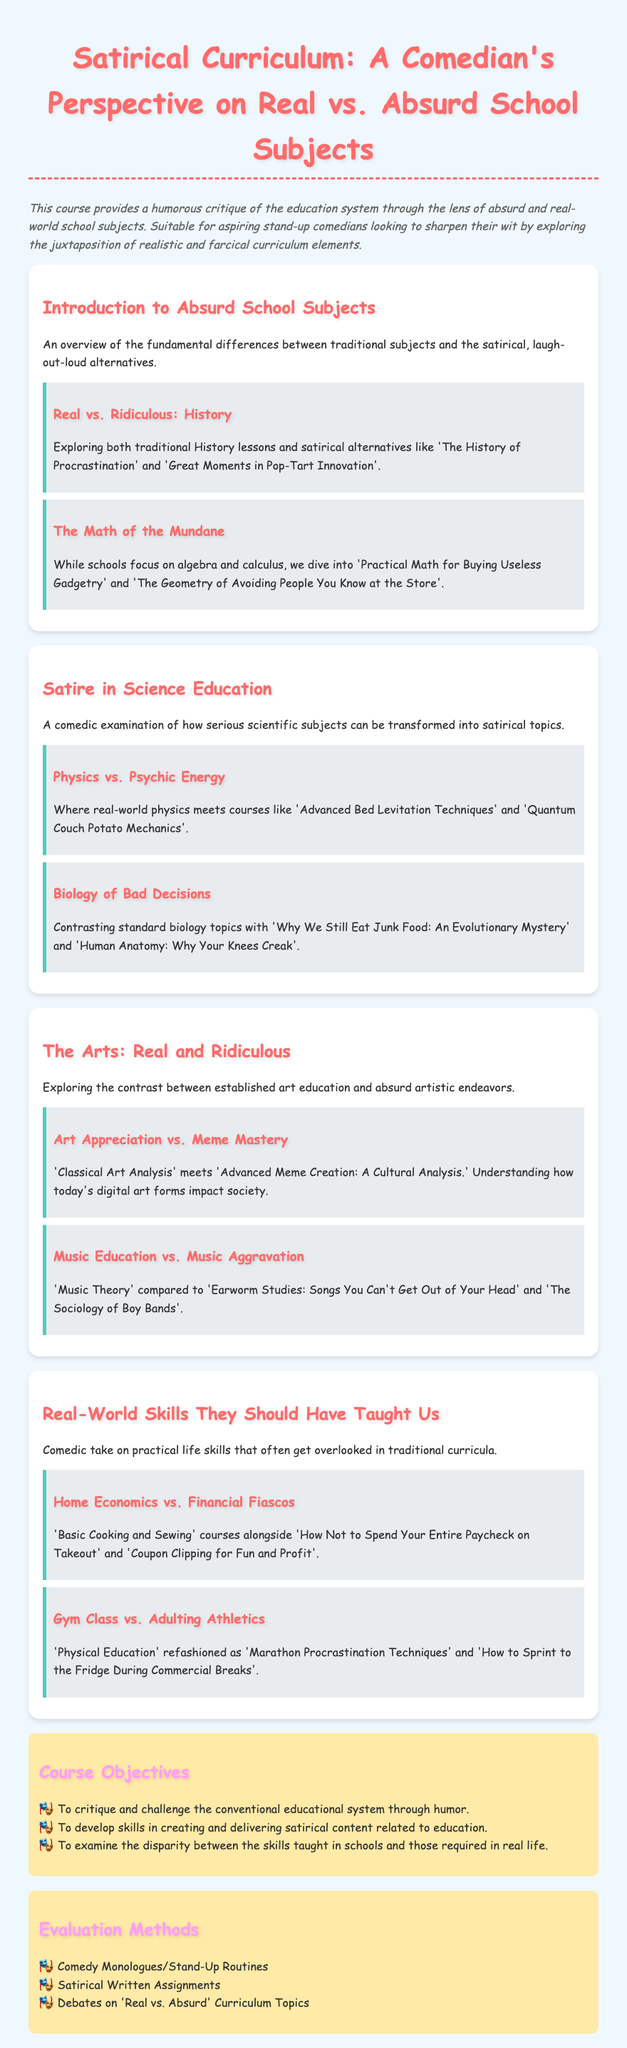What is the course title? The course title is mentioned at the top of the syllabus.
Answer: Satirical Curriculum: A Comedian's Perspective on Real vs. Absurd School Subjects How many units are there in the syllabus? The syllabus lists several distinct sections, each categorized as a unit.
Answer: Four What is the main objective of the course? The objectives section outlines the key aims of the course.
Answer: To critique and challenge the conventional educational system through humor Name one absurd school subject mentioned in the syllabus. The syllabus provides examples of humorous subjects within its content.
Answer: The History of Procrastination What is one of the evaluation methods listed? The evaluation section specifies ways students will be assessed throughout the course.
Answer: Comedy Monologues/Stand-Up Routines What type of humor does this syllabus primarily focus on? The course description explains the overarching theme of the syllabus.
Answer: Satirical What is the contrasting subject to 'Home Economics' mentioned? The syllabus discusses various absurd alternatives to standard subjects.
Answer: Financial Fiascos List one topic explored in the 'Arts' unit. The 'Arts' unit focuses on contrasting various art education styles.
Answer: Art Appreciation vs. Meme Mastery 